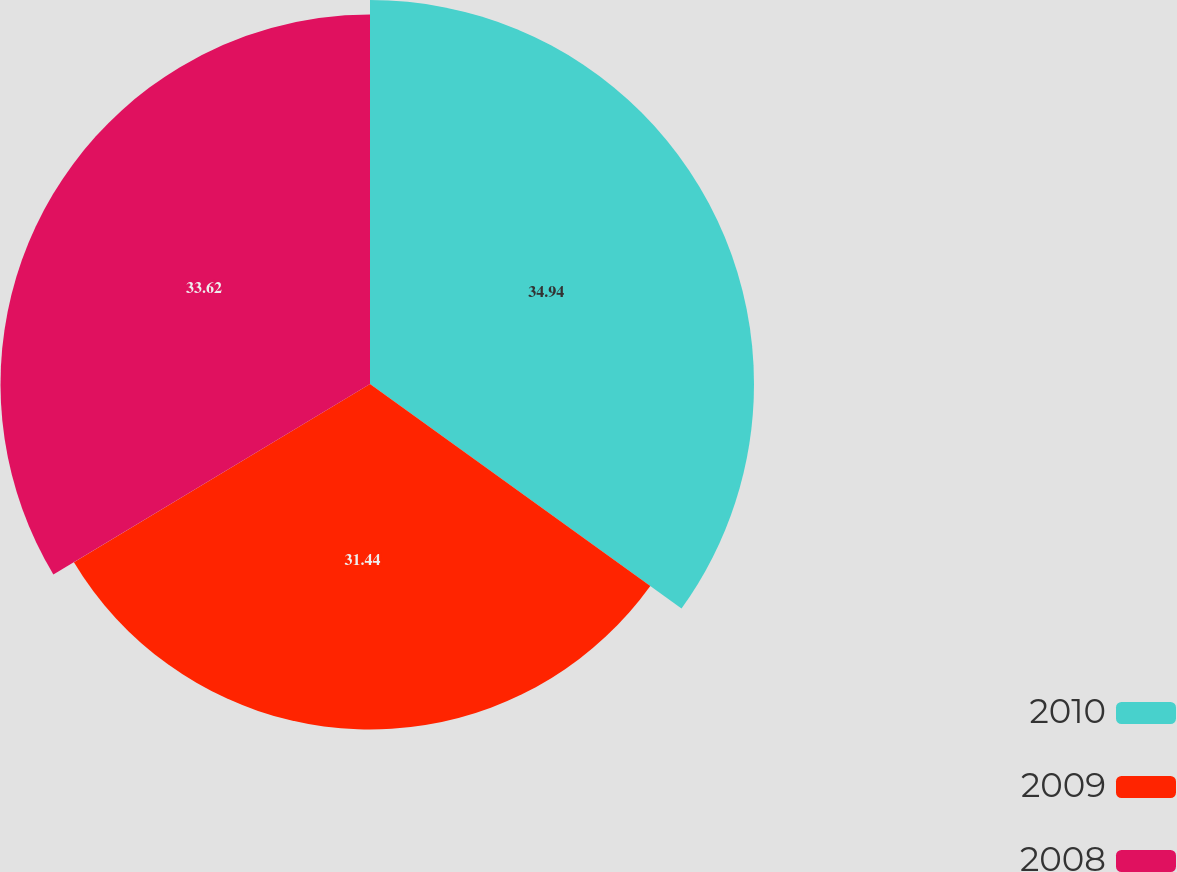Convert chart to OTSL. <chart><loc_0><loc_0><loc_500><loc_500><pie_chart><fcel>2010<fcel>2009<fcel>2008<nl><fcel>34.94%<fcel>31.44%<fcel>33.62%<nl></chart> 